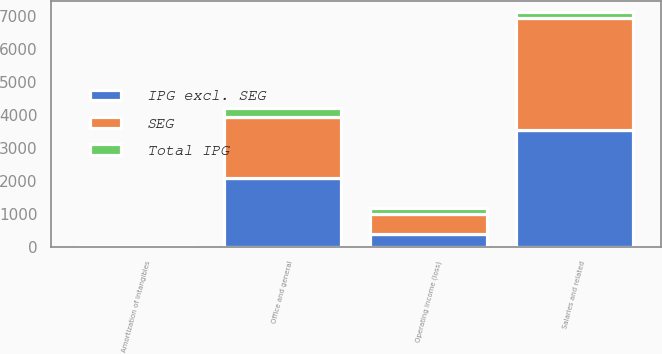Convert chart to OTSL. <chart><loc_0><loc_0><loc_500><loc_500><stacked_bar_chart><ecel><fcel>Salaries and related<fcel>Office and general<fcel>Amortization of intangibles<fcel>Operating income (loss)<nl><fcel>SEG<fcel>3367.3<fcel>1849<fcel>10.3<fcel>596.2<nl><fcel>Total IPG<fcel>181.7<fcel>247.6<fcel>2.7<fcel>190.4<nl><fcel>IPG excl. SEG<fcel>3549<fcel>2096.6<fcel>13<fcel>405.8<nl></chart> 